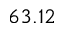<formula> <loc_0><loc_0><loc_500><loc_500>6 3 . 1 2</formula> 